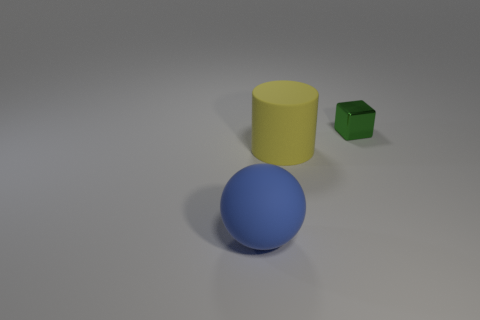Add 3 big yellow things. How many objects exist? 6 Subtract all cylinders. How many objects are left? 2 Subtract 1 blue balls. How many objects are left? 2 Subtract all small green objects. Subtract all red shiny objects. How many objects are left? 2 Add 3 tiny metallic blocks. How many tiny metallic blocks are left? 4 Add 1 large green cylinders. How many large green cylinders exist? 1 